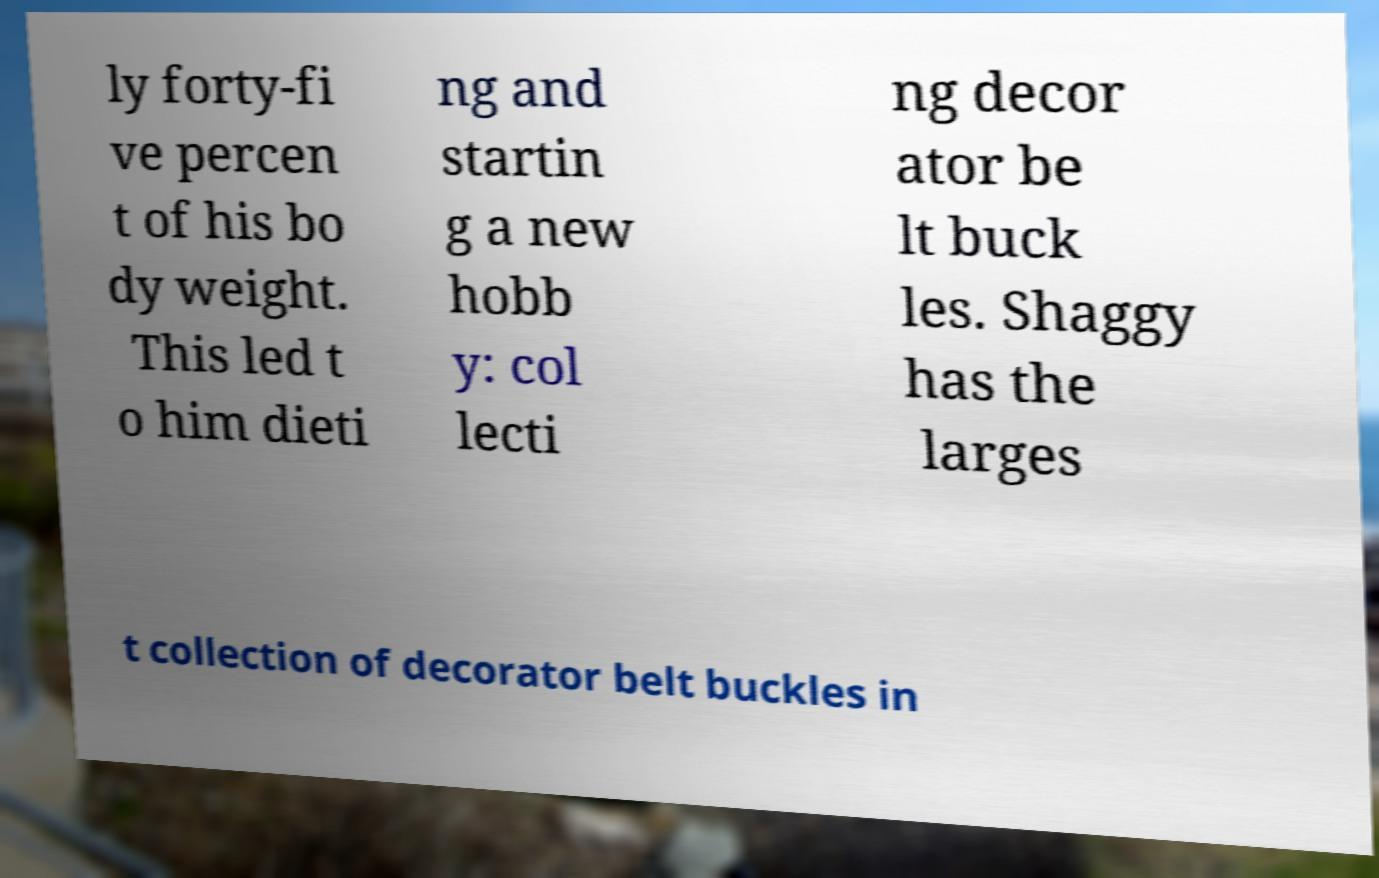There's text embedded in this image that I need extracted. Can you transcribe it verbatim? ly forty-fi ve percen t of his bo dy weight. This led t o him dieti ng and startin g a new hobb y: col lecti ng decor ator be lt buck les. Shaggy has the larges t collection of decorator belt buckles in 